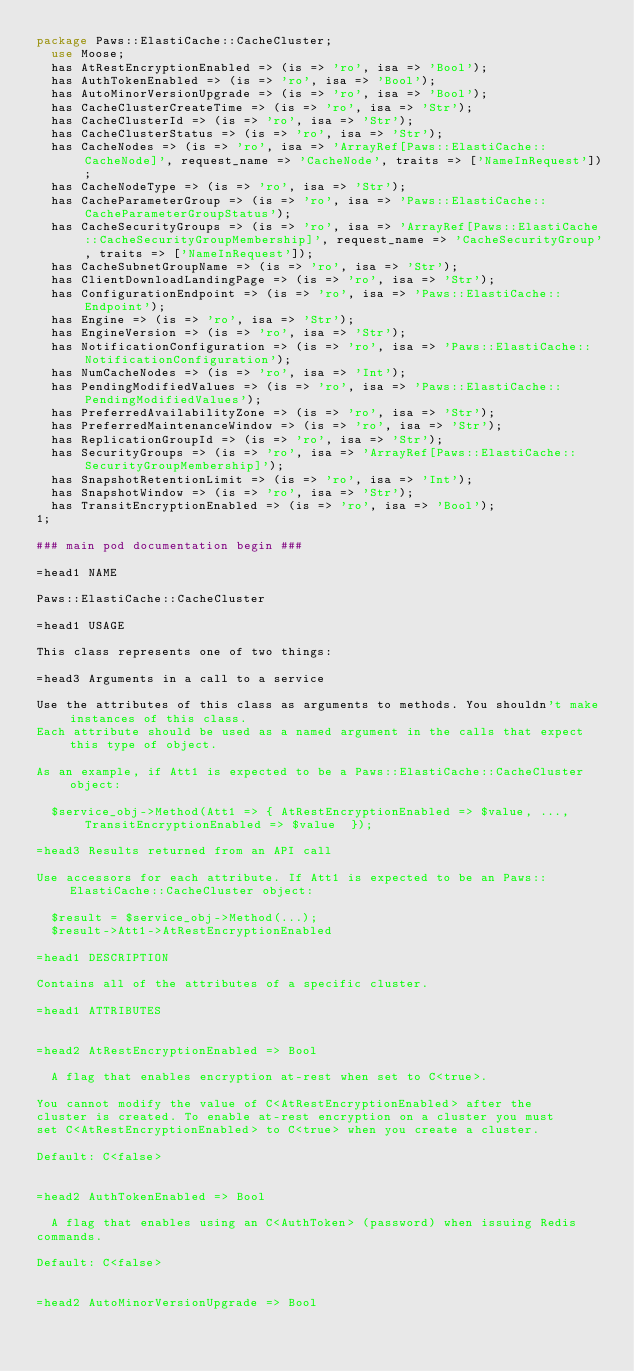<code> <loc_0><loc_0><loc_500><loc_500><_Perl_>package Paws::ElastiCache::CacheCluster;
  use Moose;
  has AtRestEncryptionEnabled => (is => 'ro', isa => 'Bool');
  has AuthTokenEnabled => (is => 'ro', isa => 'Bool');
  has AutoMinorVersionUpgrade => (is => 'ro', isa => 'Bool');
  has CacheClusterCreateTime => (is => 'ro', isa => 'Str');
  has CacheClusterId => (is => 'ro', isa => 'Str');
  has CacheClusterStatus => (is => 'ro', isa => 'Str');
  has CacheNodes => (is => 'ro', isa => 'ArrayRef[Paws::ElastiCache::CacheNode]', request_name => 'CacheNode', traits => ['NameInRequest']);
  has CacheNodeType => (is => 'ro', isa => 'Str');
  has CacheParameterGroup => (is => 'ro', isa => 'Paws::ElastiCache::CacheParameterGroupStatus');
  has CacheSecurityGroups => (is => 'ro', isa => 'ArrayRef[Paws::ElastiCache::CacheSecurityGroupMembership]', request_name => 'CacheSecurityGroup', traits => ['NameInRequest']);
  has CacheSubnetGroupName => (is => 'ro', isa => 'Str');
  has ClientDownloadLandingPage => (is => 'ro', isa => 'Str');
  has ConfigurationEndpoint => (is => 'ro', isa => 'Paws::ElastiCache::Endpoint');
  has Engine => (is => 'ro', isa => 'Str');
  has EngineVersion => (is => 'ro', isa => 'Str');
  has NotificationConfiguration => (is => 'ro', isa => 'Paws::ElastiCache::NotificationConfiguration');
  has NumCacheNodes => (is => 'ro', isa => 'Int');
  has PendingModifiedValues => (is => 'ro', isa => 'Paws::ElastiCache::PendingModifiedValues');
  has PreferredAvailabilityZone => (is => 'ro', isa => 'Str');
  has PreferredMaintenanceWindow => (is => 'ro', isa => 'Str');
  has ReplicationGroupId => (is => 'ro', isa => 'Str');
  has SecurityGroups => (is => 'ro', isa => 'ArrayRef[Paws::ElastiCache::SecurityGroupMembership]');
  has SnapshotRetentionLimit => (is => 'ro', isa => 'Int');
  has SnapshotWindow => (is => 'ro', isa => 'Str');
  has TransitEncryptionEnabled => (is => 'ro', isa => 'Bool');
1;

### main pod documentation begin ###

=head1 NAME

Paws::ElastiCache::CacheCluster

=head1 USAGE

This class represents one of two things:

=head3 Arguments in a call to a service

Use the attributes of this class as arguments to methods. You shouldn't make instances of this class. 
Each attribute should be used as a named argument in the calls that expect this type of object.

As an example, if Att1 is expected to be a Paws::ElastiCache::CacheCluster object:

  $service_obj->Method(Att1 => { AtRestEncryptionEnabled => $value, ..., TransitEncryptionEnabled => $value  });

=head3 Results returned from an API call

Use accessors for each attribute. If Att1 is expected to be an Paws::ElastiCache::CacheCluster object:

  $result = $service_obj->Method(...);
  $result->Att1->AtRestEncryptionEnabled

=head1 DESCRIPTION

Contains all of the attributes of a specific cluster.

=head1 ATTRIBUTES


=head2 AtRestEncryptionEnabled => Bool

  A flag that enables encryption at-rest when set to C<true>.

You cannot modify the value of C<AtRestEncryptionEnabled> after the
cluster is created. To enable at-rest encryption on a cluster you must
set C<AtRestEncryptionEnabled> to C<true> when you create a cluster.

Default: C<false>


=head2 AuthTokenEnabled => Bool

  A flag that enables using an C<AuthToken> (password) when issuing Redis
commands.

Default: C<false>


=head2 AutoMinorVersionUpgrade => Bool
</code> 